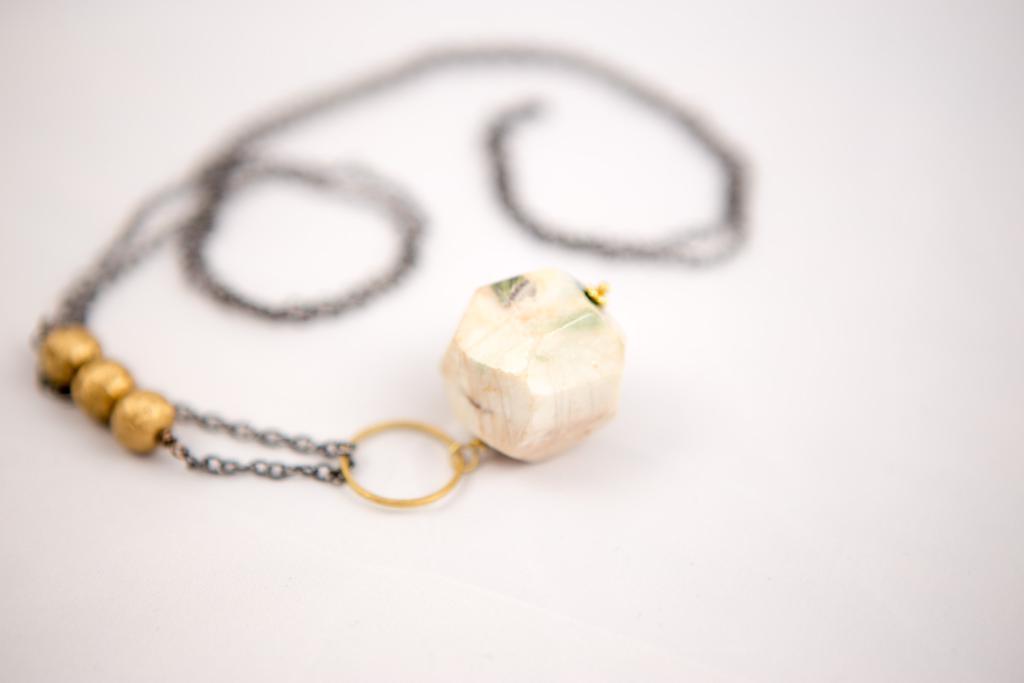Please provide a concise description of this image. In the image in the center, we can see one chain and pendant. 